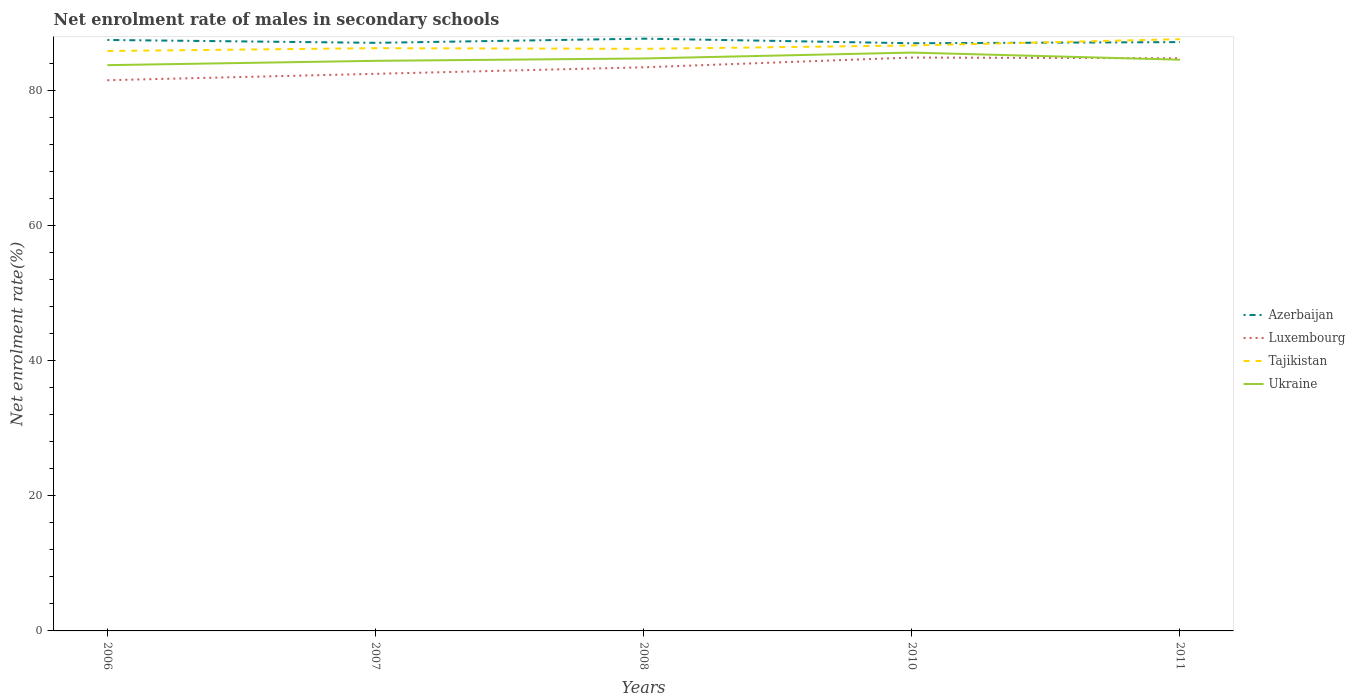Does the line corresponding to Tajikistan intersect with the line corresponding to Luxembourg?
Offer a terse response. No. Across all years, what is the maximum net enrolment rate of males in secondary schools in Ukraine?
Your response must be concise. 83.71. What is the total net enrolment rate of males in secondary schools in Tajikistan in the graph?
Give a very brief answer. 0.1. What is the difference between the highest and the second highest net enrolment rate of males in secondary schools in Ukraine?
Provide a succinct answer. 1.86. What is the difference between the highest and the lowest net enrolment rate of males in secondary schools in Luxembourg?
Provide a succinct answer. 3. How many lines are there?
Keep it short and to the point. 4. How many years are there in the graph?
Ensure brevity in your answer.  5. What is the difference between two consecutive major ticks on the Y-axis?
Make the answer very short. 20. Are the values on the major ticks of Y-axis written in scientific E-notation?
Your response must be concise. No. Does the graph contain any zero values?
Provide a short and direct response. No. Does the graph contain grids?
Your answer should be very brief. No. How many legend labels are there?
Offer a very short reply. 4. How are the legend labels stacked?
Your answer should be compact. Vertical. What is the title of the graph?
Your response must be concise. Net enrolment rate of males in secondary schools. What is the label or title of the Y-axis?
Provide a succinct answer. Net enrolment rate(%). What is the Net enrolment rate(%) of Azerbaijan in 2006?
Your answer should be compact. 87.44. What is the Net enrolment rate(%) of Luxembourg in 2006?
Your answer should be compact. 81.49. What is the Net enrolment rate(%) in Tajikistan in 2006?
Provide a succinct answer. 85.81. What is the Net enrolment rate(%) of Ukraine in 2006?
Ensure brevity in your answer.  83.71. What is the Net enrolment rate(%) of Azerbaijan in 2007?
Provide a short and direct response. 87.02. What is the Net enrolment rate(%) in Luxembourg in 2007?
Offer a terse response. 82.43. What is the Net enrolment rate(%) in Tajikistan in 2007?
Ensure brevity in your answer.  86.23. What is the Net enrolment rate(%) in Ukraine in 2007?
Your response must be concise. 84.36. What is the Net enrolment rate(%) in Azerbaijan in 2008?
Give a very brief answer. 87.64. What is the Net enrolment rate(%) in Luxembourg in 2008?
Provide a short and direct response. 83.4. What is the Net enrolment rate(%) of Tajikistan in 2008?
Provide a short and direct response. 86.13. What is the Net enrolment rate(%) in Ukraine in 2008?
Provide a short and direct response. 84.7. What is the Net enrolment rate(%) of Azerbaijan in 2010?
Ensure brevity in your answer.  86.96. What is the Net enrolment rate(%) of Luxembourg in 2010?
Make the answer very short. 84.84. What is the Net enrolment rate(%) of Tajikistan in 2010?
Keep it short and to the point. 86.63. What is the Net enrolment rate(%) in Ukraine in 2010?
Provide a short and direct response. 85.57. What is the Net enrolment rate(%) of Azerbaijan in 2011?
Your answer should be very brief. 87.13. What is the Net enrolment rate(%) in Luxembourg in 2011?
Offer a terse response. 84.74. What is the Net enrolment rate(%) of Tajikistan in 2011?
Your answer should be compact. 87.56. What is the Net enrolment rate(%) in Ukraine in 2011?
Ensure brevity in your answer.  84.52. Across all years, what is the maximum Net enrolment rate(%) of Azerbaijan?
Make the answer very short. 87.64. Across all years, what is the maximum Net enrolment rate(%) of Luxembourg?
Ensure brevity in your answer.  84.84. Across all years, what is the maximum Net enrolment rate(%) of Tajikistan?
Your response must be concise. 87.56. Across all years, what is the maximum Net enrolment rate(%) of Ukraine?
Your response must be concise. 85.57. Across all years, what is the minimum Net enrolment rate(%) of Azerbaijan?
Provide a short and direct response. 86.96. Across all years, what is the minimum Net enrolment rate(%) in Luxembourg?
Your answer should be very brief. 81.49. Across all years, what is the minimum Net enrolment rate(%) in Tajikistan?
Offer a terse response. 85.81. Across all years, what is the minimum Net enrolment rate(%) of Ukraine?
Provide a short and direct response. 83.71. What is the total Net enrolment rate(%) in Azerbaijan in the graph?
Ensure brevity in your answer.  436.18. What is the total Net enrolment rate(%) in Luxembourg in the graph?
Your response must be concise. 416.89. What is the total Net enrolment rate(%) in Tajikistan in the graph?
Offer a terse response. 432.35. What is the total Net enrolment rate(%) of Ukraine in the graph?
Provide a succinct answer. 422.86. What is the difference between the Net enrolment rate(%) in Azerbaijan in 2006 and that in 2007?
Your answer should be compact. 0.43. What is the difference between the Net enrolment rate(%) of Luxembourg in 2006 and that in 2007?
Your answer should be very brief. -0.95. What is the difference between the Net enrolment rate(%) in Tajikistan in 2006 and that in 2007?
Ensure brevity in your answer.  -0.42. What is the difference between the Net enrolment rate(%) of Ukraine in 2006 and that in 2007?
Keep it short and to the point. -0.64. What is the difference between the Net enrolment rate(%) in Azerbaijan in 2006 and that in 2008?
Offer a very short reply. -0.19. What is the difference between the Net enrolment rate(%) of Luxembourg in 2006 and that in 2008?
Your answer should be very brief. -1.91. What is the difference between the Net enrolment rate(%) of Tajikistan in 2006 and that in 2008?
Your response must be concise. -0.32. What is the difference between the Net enrolment rate(%) of Ukraine in 2006 and that in 2008?
Keep it short and to the point. -0.99. What is the difference between the Net enrolment rate(%) in Azerbaijan in 2006 and that in 2010?
Make the answer very short. 0.49. What is the difference between the Net enrolment rate(%) of Luxembourg in 2006 and that in 2010?
Provide a succinct answer. -3.35. What is the difference between the Net enrolment rate(%) in Tajikistan in 2006 and that in 2010?
Offer a very short reply. -0.82. What is the difference between the Net enrolment rate(%) of Ukraine in 2006 and that in 2010?
Keep it short and to the point. -1.86. What is the difference between the Net enrolment rate(%) of Azerbaijan in 2006 and that in 2011?
Make the answer very short. 0.32. What is the difference between the Net enrolment rate(%) of Luxembourg in 2006 and that in 2011?
Make the answer very short. -3.25. What is the difference between the Net enrolment rate(%) in Tajikistan in 2006 and that in 2011?
Your answer should be compact. -1.75. What is the difference between the Net enrolment rate(%) of Ukraine in 2006 and that in 2011?
Offer a very short reply. -0.81. What is the difference between the Net enrolment rate(%) in Azerbaijan in 2007 and that in 2008?
Give a very brief answer. -0.62. What is the difference between the Net enrolment rate(%) of Luxembourg in 2007 and that in 2008?
Make the answer very short. -0.96. What is the difference between the Net enrolment rate(%) of Tajikistan in 2007 and that in 2008?
Your answer should be very brief. 0.1. What is the difference between the Net enrolment rate(%) of Ukraine in 2007 and that in 2008?
Make the answer very short. -0.35. What is the difference between the Net enrolment rate(%) in Azerbaijan in 2007 and that in 2010?
Offer a very short reply. 0.06. What is the difference between the Net enrolment rate(%) in Luxembourg in 2007 and that in 2010?
Give a very brief answer. -2.41. What is the difference between the Net enrolment rate(%) in Tajikistan in 2007 and that in 2010?
Your answer should be compact. -0.4. What is the difference between the Net enrolment rate(%) in Ukraine in 2007 and that in 2010?
Give a very brief answer. -1.22. What is the difference between the Net enrolment rate(%) in Azerbaijan in 2007 and that in 2011?
Make the answer very short. -0.11. What is the difference between the Net enrolment rate(%) of Luxembourg in 2007 and that in 2011?
Make the answer very short. -2.3. What is the difference between the Net enrolment rate(%) in Tajikistan in 2007 and that in 2011?
Give a very brief answer. -1.33. What is the difference between the Net enrolment rate(%) in Ukraine in 2007 and that in 2011?
Give a very brief answer. -0.17. What is the difference between the Net enrolment rate(%) in Azerbaijan in 2008 and that in 2010?
Keep it short and to the point. 0.68. What is the difference between the Net enrolment rate(%) of Luxembourg in 2008 and that in 2010?
Your response must be concise. -1.44. What is the difference between the Net enrolment rate(%) in Tajikistan in 2008 and that in 2010?
Ensure brevity in your answer.  -0.49. What is the difference between the Net enrolment rate(%) of Ukraine in 2008 and that in 2010?
Ensure brevity in your answer.  -0.87. What is the difference between the Net enrolment rate(%) in Azerbaijan in 2008 and that in 2011?
Keep it short and to the point. 0.51. What is the difference between the Net enrolment rate(%) in Luxembourg in 2008 and that in 2011?
Give a very brief answer. -1.34. What is the difference between the Net enrolment rate(%) of Tajikistan in 2008 and that in 2011?
Keep it short and to the point. -1.43. What is the difference between the Net enrolment rate(%) in Ukraine in 2008 and that in 2011?
Ensure brevity in your answer.  0.18. What is the difference between the Net enrolment rate(%) of Azerbaijan in 2010 and that in 2011?
Provide a succinct answer. -0.17. What is the difference between the Net enrolment rate(%) in Luxembourg in 2010 and that in 2011?
Make the answer very short. 0.11. What is the difference between the Net enrolment rate(%) of Tajikistan in 2010 and that in 2011?
Your answer should be very brief. -0.93. What is the difference between the Net enrolment rate(%) of Ukraine in 2010 and that in 2011?
Offer a terse response. 1.05. What is the difference between the Net enrolment rate(%) in Azerbaijan in 2006 and the Net enrolment rate(%) in Luxembourg in 2007?
Offer a very short reply. 5.01. What is the difference between the Net enrolment rate(%) of Azerbaijan in 2006 and the Net enrolment rate(%) of Tajikistan in 2007?
Provide a succinct answer. 1.22. What is the difference between the Net enrolment rate(%) of Azerbaijan in 2006 and the Net enrolment rate(%) of Ukraine in 2007?
Give a very brief answer. 3.09. What is the difference between the Net enrolment rate(%) of Luxembourg in 2006 and the Net enrolment rate(%) of Tajikistan in 2007?
Keep it short and to the point. -4.74. What is the difference between the Net enrolment rate(%) in Luxembourg in 2006 and the Net enrolment rate(%) in Ukraine in 2007?
Make the answer very short. -2.87. What is the difference between the Net enrolment rate(%) in Tajikistan in 2006 and the Net enrolment rate(%) in Ukraine in 2007?
Your response must be concise. 1.46. What is the difference between the Net enrolment rate(%) of Azerbaijan in 2006 and the Net enrolment rate(%) of Luxembourg in 2008?
Give a very brief answer. 4.05. What is the difference between the Net enrolment rate(%) of Azerbaijan in 2006 and the Net enrolment rate(%) of Tajikistan in 2008?
Offer a terse response. 1.31. What is the difference between the Net enrolment rate(%) of Azerbaijan in 2006 and the Net enrolment rate(%) of Ukraine in 2008?
Provide a short and direct response. 2.74. What is the difference between the Net enrolment rate(%) of Luxembourg in 2006 and the Net enrolment rate(%) of Tajikistan in 2008?
Keep it short and to the point. -4.65. What is the difference between the Net enrolment rate(%) in Luxembourg in 2006 and the Net enrolment rate(%) in Ukraine in 2008?
Offer a very short reply. -3.22. What is the difference between the Net enrolment rate(%) in Tajikistan in 2006 and the Net enrolment rate(%) in Ukraine in 2008?
Ensure brevity in your answer.  1.11. What is the difference between the Net enrolment rate(%) of Azerbaijan in 2006 and the Net enrolment rate(%) of Luxembourg in 2010?
Make the answer very short. 2.6. What is the difference between the Net enrolment rate(%) in Azerbaijan in 2006 and the Net enrolment rate(%) in Tajikistan in 2010?
Provide a short and direct response. 0.82. What is the difference between the Net enrolment rate(%) of Azerbaijan in 2006 and the Net enrolment rate(%) of Ukraine in 2010?
Make the answer very short. 1.87. What is the difference between the Net enrolment rate(%) of Luxembourg in 2006 and the Net enrolment rate(%) of Tajikistan in 2010?
Ensure brevity in your answer.  -5.14. What is the difference between the Net enrolment rate(%) in Luxembourg in 2006 and the Net enrolment rate(%) in Ukraine in 2010?
Your answer should be very brief. -4.09. What is the difference between the Net enrolment rate(%) in Tajikistan in 2006 and the Net enrolment rate(%) in Ukraine in 2010?
Provide a short and direct response. 0.24. What is the difference between the Net enrolment rate(%) of Azerbaijan in 2006 and the Net enrolment rate(%) of Luxembourg in 2011?
Provide a succinct answer. 2.71. What is the difference between the Net enrolment rate(%) in Azerbaijan in 2006 and the Net enrolment rate(%) in Tajikistan in 2011?
Provide a succinct answer. -0.12. What is the difference between the Net enrolment rate(%) in Azerbaijan in 2006 and the Net enrolment rate(%) in Ukraine in 2011?
Your response must be concise. 2.92. What is the difference between the Net enrolment rate(%) in Luxembourg in 2006 and the Net enrolment rate(%) in Tajikistan in 2011?
Keep it short and to the point. -6.07. What is the difference between the Net enrolment rate(%) of Luxembourg in 2006 and the Net enrolment rate(%) of Ukraine in 2011?
Give a very brief answer. -3.03. What is the difference between the Net enrolment rate(%) in Tajikistan in 2006 and the Net enrolment rate(%) in Ukraine in 2011?
Give a very brief answer. 1.29. What is the difference between the Net enrolment rate(%) of Azerbaijan in 2007 and the Net enrolment rate(%) of Luxembourg in 2008?
Offer a terse response. 3.62. What is the difference between the Net enrolment rate(%) of Azerbaijan in 2007 and the Net enrolment rate(%) of Tajikistan in 2008?
Offer a very short reply. 0.89. What is the difference between the Net enrolment rate(%) of Azerbaijan in 2007 and the Net enrolment rate(%) of Ukraine in 2008?
Offer a terse response. 2.32. What is the difference between the Net enrolment rate(%) of Luxembourg in 2007 and the Net enrolment rate(%) of Tajikistan in 2008?
Ensure brevity in your answer.  -3.7. What is the difference between the Net enrolment rate(%) of Luxembourg in 2007 and the Net enrolment rate(%) of Ukraine in 2008?
Provide a succinct answer. -2.27. What is the difference between the Net enrolment rate(%) in Tajikistan in 2007 and the Net enrolment rate(%) in Ukraine in 2008?
Give a very brief answer. 1.52. What is the difference between the Net enrolment rate(%) in Azerbaijan in 2007 and the Net enrolment rate(%) in Luxembourg in 2010?
Provide a succinct answer. 2.18. What is the difference between the Net enrolment rate(%) of Azerbaijan in 2007 and the Net enrolment rate(%) of Tajikistan in 2010?
Your response must be concise. 0.39. What is the difference between the Net enrolment rate(%) in Azerbaijan in 2007 and the Net enrolment rate(%) in Ukraine in 2010?
Your answer should be compact. 1.45. What is the difference between the Net enrolment rate(%) of Luxembourg in 2007 and the Net enrolment rate(%) of Tajikistan in 2010?
Keep it short and to the point. -4.19. What is the difference between the Net enrolment rate(%) of Luxembourg in 2007 and the Net enrolment rate(%) of Ukraine in 2010?
Your answer should be compact. -3.14. What is the difference between the Net enrolment rate(%) of Tajikistan in 2007 and the Net enrolment rate(%) of Ukraine in 2010?
Offer a very short reply. 0.66. What is the difference between the Net enrolment rate(%) in Azerbaijan in 2007 and the Net enrolment rate(%) in Luxembourg in 2011?
Keep it short and to the point. 2.28. What is the difference between the Net enrolment rate(%) of Azerbaijan in 2007 and the Net enrolment rate(%) of Tajikistan in 2011?
Your response must be concise. -0.54. What is the difference between the Net enrolment rate(%) in Azerbaijan in 2007 and the Net enrolment rate(%) in Ukraine in 2011?
Your response must be concise. 2.5. What is the difference between the Net enrolment rate(%) in Luxembourg in 2007 and the Net enrolment rate(%) in Tajikistan in 2011?
Ensure brevity in your answer.  -5.13. What is the difference between the Net enrolment rate(%) of Luxembourg in 2007 and the Net enrolment rate(%) of Ukraine in 2011?
Ensure brevity in your answer.  -2.09. What is the difference between the Net enrolment rate(%) in Tajikistan in 2007 and the Net enrolment rate(%) in Ukraine in 2011?
Provide a short and direct response. 1.71. What is the difference between the Net enrolment rate(%) of Azerbaijan in 2008 and the Net enrolment rate(%) of Luxembourg in 2010?
Provide a short and direct response. 2.79. What is the difference between the Net enrolment rate(%) in Azerbaijan in 2008 and the Net enrolment rate(%) in Tajikistan in 2010?
Your answer should be very brief. 1.01. What is the difference between the Net enrolment rate(%) of Azerbaijan in 2008 and the Net enrolment rate(%) of Ukraine in 2010?
Offer a very short reply. 2.06. What is the difference between the Net enrolment rate(%) in Luxembourg in 2008 and the Net enrolment rate(%) in Tajikistan in 2010?
Your answer should be compact. -3.23. What is the difference between the Net enrolment rate(%) in Luxembourg in 2008 and the Net enrolment rate(%) in Ukraine in 2010?
Your response must be concise. -2.17. What is the difference between the Net enrolment rate(%) in Tajikistan in 2008 and the Net enrolment rate(%) in Ukraine in 2010?
Offer a very short reply. 0.56. What is the difference between the Net enrolment rate(%) of Azerbaijan in 2008 and the Net enrolment rate(%) of Luxembourg in 2011?
Give a very brief answer. 2.9. What is the difference between the Net enrolment rate(%) of Azerbaijan in 2008 and the Net enrolment rate(%) of Tajikistan in 2011?
Offer a terse response. 0.08. What is the difference between the Net enrolment rate(%) of Azerbaijan in 2008 and the Net enrolment rate(%) of Ukraine in 2011?
Offer a terse response. 3.11. What is the difference between the Net enrolment rate(%) of Luxembourg in 2008 and the Net enrolment rate(%) of Tajikistan in 2011?
Keep it short and to the point. -4.16. What is the difference between the Net enrolment rate(%) in Luxembourg in 2008 and the Net enrolment rate(%) in Ukraine in 2011?
Offer a very short reply. -1.12. What is the difference between the Net enrolment rate(%) in Tajikistan in 2008 and the Net enrolment rate(%) in Ukraine in 2011?
Offer a terse response. 1.61. What is the difference between the Net enrolment rate(%) of Azerbaijan in 2010 and the Net enrolment rate(%) of Luxembourg in 2011?
Provide a succinct answer. 2.22. What is the difference between the Net enrolment rate(%) in Azerbaijan in 2010 and the Net enrolment rate(%) in Tajikistan in 2011?
Your answer should be compact. -0.6. What is the difference between the Net enrolment rate(%) in Azerbaijan in 2010 and the Net enrolment rate(%) in Ukraine in 2011?
Give a very brief answer. 2.44. What is the difference between the Net enrolment rate(%) in Luxembourg in 2010 and the Net enrolment rate(%) in Tajikistan in 2011?
Your response must be concise. -2.72. What is the difference between the Net enrolment rate(%) in Luxembourg in 2010 and the Net enrolment rate(%) in Ukraine in 2011?
Your answer should be very brief. 0.32. What is the difference between the Net enrolment rate(%) of Tajikistan in 2010 and the Net enrolment rate(%) of Ukraine in 2011?
Make the answer very short. 2.11. What is the average Net enrolment rate(%) of Azerbaijan per year?
Your answer should be very brief. 87.24. What is the average Net enrolment rate(%) in Luxembourg per year?
Your response must be concise. 83.38. What is the average Net enrolment rate(%) of Tajikistan per year?
Your response must be concise. 86.47. What is the average Net enrolment rate(%) in Ukraine per year?
Your answer should be compact. 84.57. In the year 2006, what is the difference between the Net enrolment rate(%) in Azerbaijan and Net enrolment rate(%) in Luxembourg?
Your answer should be very brief. 5.96. In the year 2006, what is the difference between the Net enrolment rate(%) of Azerbaijan and Net enrolment rate(%) of Tajikistan?
Offer a terse response. 1.63. In the year 2006, what is the difference between the Net enrolment rate(%) in Azerbaijan and Net enrolment rate(%) in Ukraine?
Your answer should be very brief. 3.73. In the year 2006, what is the difference between the Net enrolment rate(%) of Luxembourg and Net enrolment rate(%) of Tajikistan?
Provide a short and direct response. -4.32. In the year 2006, what is the difference between the Net enrolment rate(%) of Luxembourg and Net enrolment rate(%) of Ukraine?
Provide a short and direct response. -2.23. In the year 2006, what is the difference between the Net enrolment rate(%) of Tajikistan and Net enrolment rate(%) of Ukraine?
Provide a succinct answer. 2.1. In the year 2007, what is the difference between the Net enrolment rate(%) of Azerbaijan and Net enrolment rate(%) of Luxembourg?
Make the answer very short. 4.59. In the year 2007, what is the difference between the Net enrolment rate(%) of Azerbaijan and Net enrolment rate(%) of Tajikistan?
Make the answer very short. 0.79. In the year 2007, what is the difference between the Net enrolment rate(%) of Azerbaijan and Net enrolment rate(%) of Ukraine?
Your response must be concise. 2.66. In the year 2007, what is the difference between the Net enrolment rate(%) of Luxembourg and Net enrolment rate(%) of Tajikistan?
Keep it short and to the point. -3.79. In the year 2007, what is the difference between the Net enrolment rate(%) of Luxembourg and Net enrolment rate(%) of Ukraine?
Your response must be concise. -1.92. In the year 2007, what is the difference between the Net enrolment rate(%) of Tajikistan and Net enrolment rate(%) of Ukraine?
Keep it short and to the point. 1.87. In the year 2008, what is the difference between the Net enrolment rate(%) of Azerbaijan and Net enrolment rate(%) of Luxembourg?
Offer a terse response. 4.24. In the year 2008, what is the difference between the Net enrolment rate(%) in Azerbaijan and Net enrolment rate(%) in Tajikistan?
Offer a very short reply. 1.5. In the year 2008, what is the difference between the Net enrolment rate(%) in Azerbaijan and Net enrolment rate(%) in Ukraine?
Provide a short and direct response. 2.93. In the year 2008, what is the difference between the Net enrolment rate(%) in Luxembourg and Net enrolment rate(%) in Tajikistan?
Keep it short and to the point. -2.73. In the year 2008, what is the difference between the Net enrolment rate(%) of Luxembourg and Net enrolment rate(%) of Ukraine?
Provide a short and direct response. -1.31. In the year 2008, what is the difference between the Net enrolment rate(%) in Tajikistan and Net enrolment rate(%) in Ukraine?
Provide a succinct answer. 1.43. In the year 2010, what is the difference between the Net enrolment rate(%) of Azerbaijan and Net enrolment rate(%) of Luxembourg?
Your response must be concise. 2.12. In the year 2010, what is the difference between the Net enrolment rate(%) in Azerbaijan and Net enrolment rate(%) in Tajikistan?
Provide a succinct answer. 0.33. In the year 2010, what is the difference between the Net enrolment rate(%) of Azerbaijan and Net enrolment rate(%) of Ukraine?
Offer a very short reply. 1.38. In the year 2010, what is the difference between the Net enrolment rate(%) in Luxembourg and Net enrolment rate(%) in Tajikistan?
Keep it short and to the point. -1.79. In the year 2010, what is the difference between the Net enrolment rate(%) in Luxembourg and Net enrolment rate(%) in Ukraine?
Offer a very short reply. -0.73. In the year 2010, what is the difference between the Net enrolment rate(%) in Tajikistan and Net enrolment rate(%) in Ukraine?
Give a very brief answer. 1.05. In the year 2011, what is the difference between the Net enrolment rate(%) of Azerbaijan and Net enrolment rate(%) of Luxembourg?
Your answer should be compact. 2.39. In the year 2011, what is the difference between the Net enrolment rate(%) of Azerbaijan and Net enrolment rate(%) of Tajikistan?
Keep it short and to the point. -0.43. In the year 2011, what is the difference between the Net enrolment rate(%) of Azerbaijan and Net enrolment rate(%) of Ukraine?
Give a very brief answer. 2.6. In the year 2011, what is the difference between the Net enrolment rate(%) in Luxembourg and Net enrolment rate(%) in Tajikistan?
Your response must be concise. -2.82. In the year 2011, what is the difference between the Net enrolment rate(%) of Luxembourg and Net enrolment rate(%) of Ukraine?
Offer a terse response. 0.21. In the year 2011, what is the difference between the Net enrolment rate(%) in Tajikistan and Net enrolment rate(%) in Ukraine?
Make the answer very short. 3.04. What is the ratio of the Net enrolment rate(%) in Azerbaijan in 2006 to that in 2007?
Your answer should be very brief. 1. What is the ratio of the Net enrolment rate(%) in Luxembourg in 2006 to that in 2007?
Offer a very short reply. 0.99. What is the ratio of the Net enrolment rate(%) in Ukraine in 2006 to that in 2007?
Ensure brevity in your answer.  0.99. What is the ratio of the Net enrolment rate(%) of Luxembourg in 2006 to that in 2008?
Ensure brevity in your answer.  0.98. What is the ratio of the Net enrolment rate(%) of Tajikistan in 2006 to that in 2008?
Provide a succinct answer. 1. What is the ratio of the Net enrolment rate(%) in Ukraine in 2006 to that in 2008?
Offer a terse response. 0.99. What is the ratio of the Net enrolment rate(%) of Azerbaijan in 2006 to that in 2010?
Ensure brevity in your answer.  1.01. What is the ratio of the Net enrolment rate(%) in Luxembourg in 2006 to that in 2010?
Your response must be concise. 0.96. What is the ratio of the Net enrolment rate(%) of Tajikistan in 2006 to that in 2010?
Ensure brevity in your answer.  0.99. What is the ratio of the Net enrolment rate(%) of Ukraine in 2006 to that in 2010?
Provide a short and direct response. 0.98. What is the ratio of the Net enrolment rate(%) in Azerbaijan in 2006 to that in 2011?
Offer a terse response. 1. What is the ratio of the Net enrolment rate(%) of Luxembourg in 2006 to that in 2011?
Give a very brief answer. 0.96. What is the ratio of the Net enrolment rate(%) in Azerbaijan in 2007 to that in 2008?
Your answer should be very brief. 0.99. What is the ratio of the Net enrolment rate(%) of Luxembourg in 2007 to that in 2008?
Ensure brevity in your answer.  0.99. What is the ratio of the Net enrolment rate(%) of Tajikistan in 2007 to that in 2008?
Ensure brevity in your answer.  1. What is the ratio of the Net enrolment rate(%) in Ukraine in 2007 to that in 2008?
Provide a succinct answer. 1. What is the ratio of the Net enrolment rate(%) in Luxembourg in 2007 to that in 2010?
Make the answer very short. 0.97. What is the ratio of the Net enrolment rate(%) in Tajikistan in 2007 to that in 2010?
Offer a terse response. 1. What is the ratio of the Net enrolment rate(%) of Ukraine in 2007 to that in 2010?
Ensure brevity in your answer.  0.99. What is the ratio of the Net enrolment rate(%) of Azerbaijan in 2007 to that in 2011?
Your response must be concise. 1. What is the ratio of the Net enrolment rate(%) of Luxembourg in 2007 to that in 2011?
Your response must be concise. 0.97. What is the ratio of the Net enrolment rate(%) in Azerbaijan in 2008 to that in 2010?
Provide a succinct answer. 1.01. What is the ratio of the Net enrolment rate(%) in Luxembourg in 2008 to that in 2010?
Offer a terse response. 0.98. What is the ratio of the Net enrolment rate(%) of Tajikistan in 2008 to that in 2010?
Offer a very short reply. 0.99. What is the ratio of the Net enrolment rate(%) of Ukraine in 2008 to that in 2010?
Your response must be concise. 0.99. What is the ratio of the Net enrolment rate(%) in Azerbaijan in 2008 to that in 2011?
Your response must be concise. 1.01. What is the ratio of the Net enrolment rate(%) of Luxembourg in 2008 to that in 2011?
Make the answer very short. 0.98. What is the ratio of the Net enrolment rate(%) of Tajikistan in 2008 to that in 2011?
Give a very brief answer. 0.98. What is the ratio of the Net enrolment rate(%) of Luxembourg in 2010 to that in 2011?
Provide a succinct answer. 1. What is the ratio of the Net enrolment rate(%) of Tajikistan in 2010 to that in 2011?
Provide a succinct answer. 0.99. What is the ratio of the Net enrolment rate(%) in Ukraine in 2010 to that in 2011?
Your answer should be very brief. 1.01. What is the difference between the highest and the second highest Net enrolment rate(%) of Azerbaijan?
Your answer should be compact. 0.19. What is the difference between the highest and the second highest Net enrolment rate(%) in Luxembourg?
Your answer should be compact. 0.11. What is the difference between the highest and the second highest Net enrolment rate(%) of Tajikistan?
Ensure brevity in your answer.  0.93. What is the difference between the highest and the second highest Net enrolment rate(%) in Ukraine?
Offer a terse response. 0.87. What is the difference between the highest and the lowest Net enrolment rate(%) in Azerbaijan?
Ensure brevity in your answer.  0.68. What is the difference between the highest and the lowest Net enrolment rate(%) of Luxembourg?
Make the answer very short. 3.35. What is the difference between the highest and the lowest Net enrolment rate(%) of Tajikistan?
Give a very brief answer. 1.75. What is the difference between the highest and the lowest Net enrolment rate(%) of Ukraine?
Your response must be concise. 1.86. 